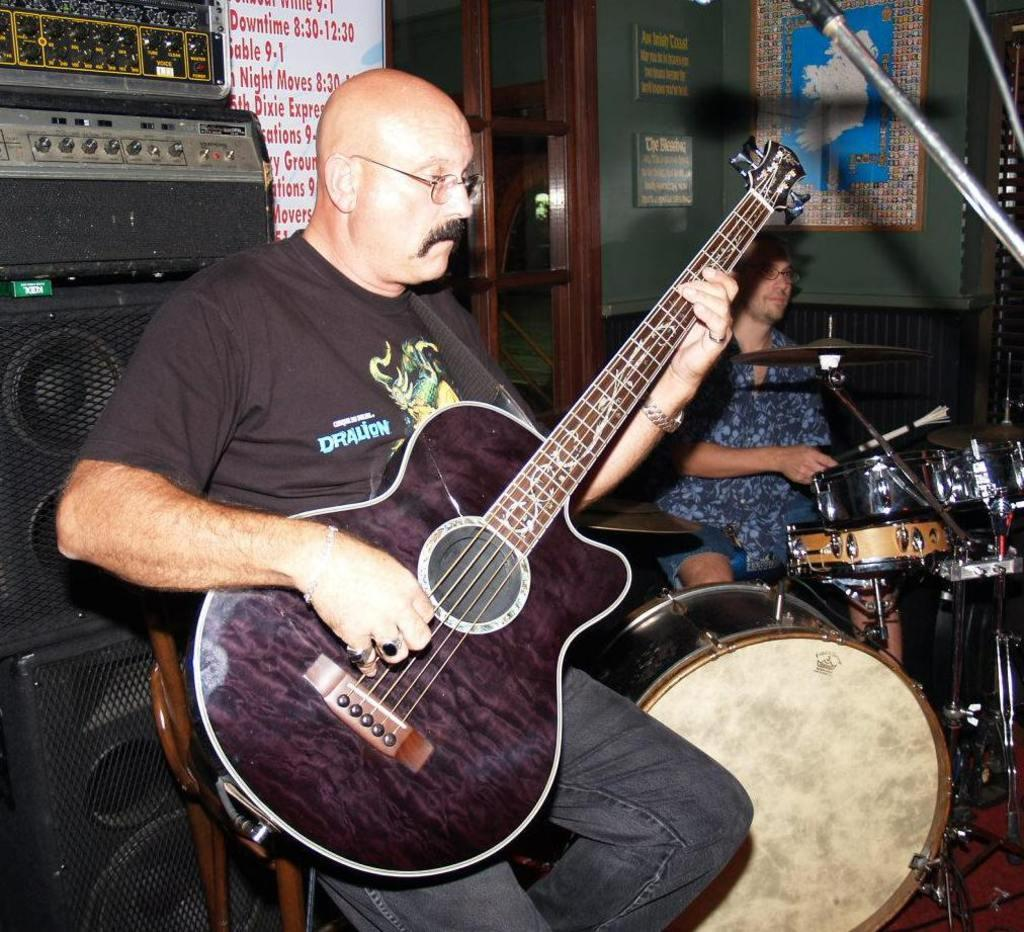What is the main activity being depicted in the image? There is a person playing a guitar in the image. Can you describe the setting in which the person is playing the guitar? The person playing the guitar is in front of a microphone. Are there any other musicians present in the image? Yes, there is another person playing drums in the image. How many hands does the guitar have in the image? The guitar does not have hands; it is an inanimate object being played by a person. What type of bead is being used as a decoration on the guitar in the image? There is no bead present as a decoration on the guitar in the image. 